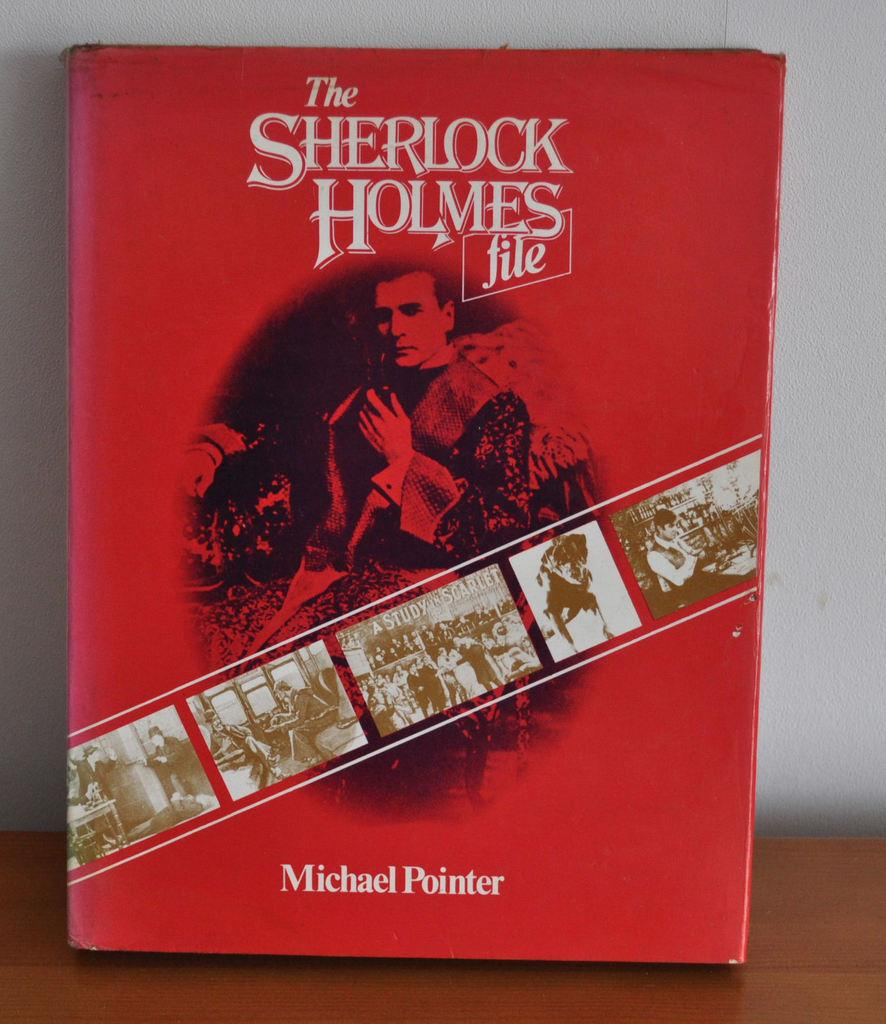<image>
Give a short and clear explanation of the subsequent image. The red and gold book is by Michael Pointer. 